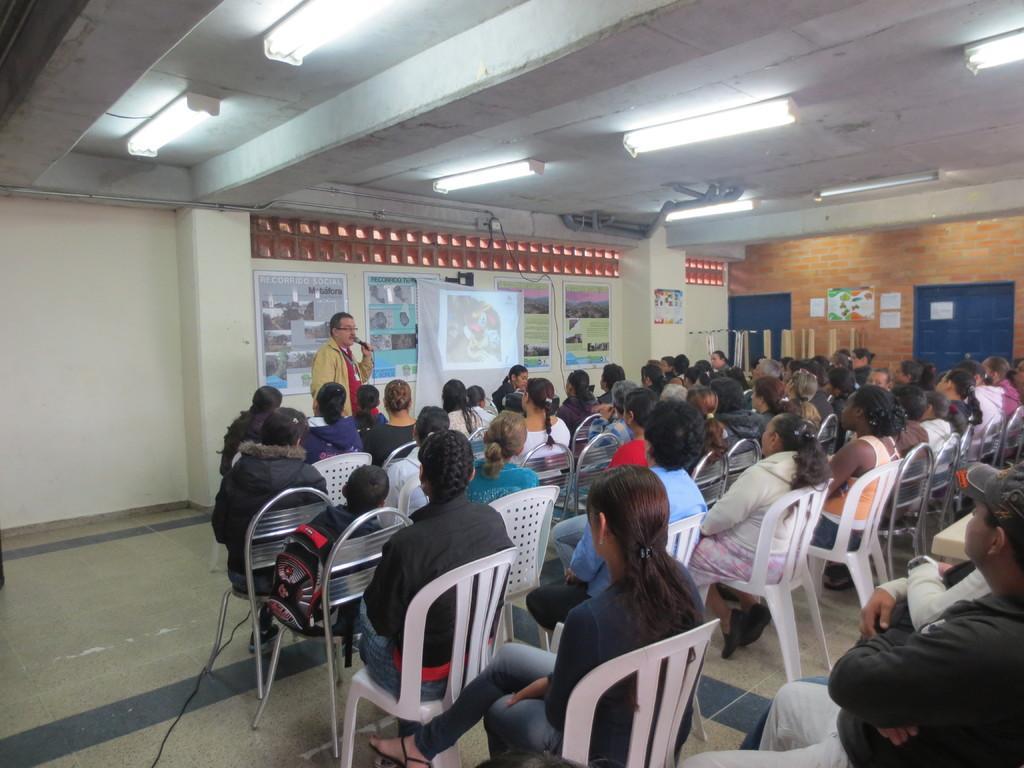In one or two sentences, can you explain what this image depicts? In the image we can see there are people sitting on the chair and there is a man standing and holding mic in his hand. Behind there are posters and projector screen on the wall. 